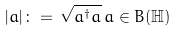Convert formula to latex. <formula><loc_0><loc_0><loc_500><loc_500>| a | \, \colon = \, \sqrt { a ^ { \dagger } a } \, a \in B ( { \mathbb { H } } )</formula> 